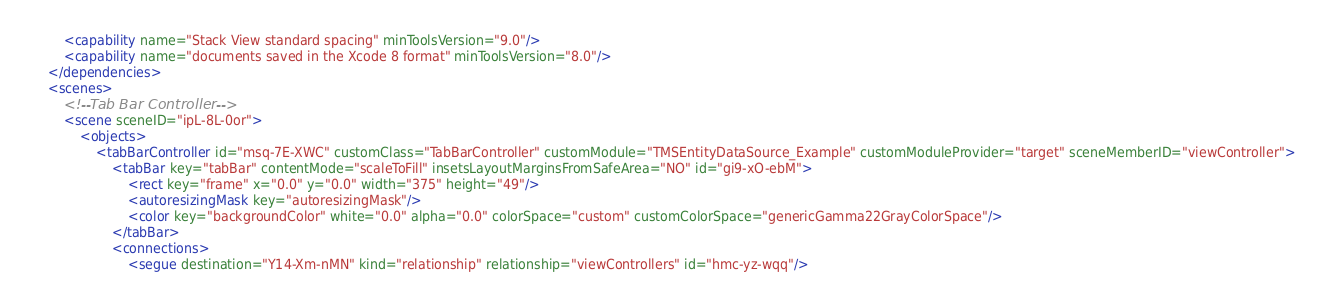<code> <loc_0><loc_0><loc_500><loc_500><_XML_>        <capability name="Stack View standard spacing" minToolsVersion="9.0"/>
        <capability name="documents saved in the Xcode 8 format" minToolsVersion="8.0"/>
    </dependencies>
    <scenes>
        <!--Tab Bar Controller-->
        <scene sceneID="ipL-8L-0or">
            <objects>
                <tabBarController id="msq-7E-XWC" customClass="TabBarController" customModule="TMSEntityDataSource_Example" customModuleProvider="target" sceneMemberID="viewController">
                    <tabBar key="tabBar" contentMode="scaleToFill" insetsLayoutMarginsFromSafeArea="NO" id="gi9-xO-ebM">
                        <rect key="frame" x="0.0" y="0.0" width="375" height="49"/>
                        <autoresizingMask key="autoresizingMask"/>
                        <color key="backgroundColor" white="0.0" alpha="0.0" colorSpace="custom" customColorSpace="genericGamma22GrayColorSpace"/>
                    </tabBar>
                    <connections>
                        <segue destination="Y14-Xm-nMN" kind="relationship" relationship="viewControllers" id="hmc-yz-wqq"/></code> 